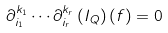<formula> <loc_0><loc_0><loc_500><loc_500>\partial _ { i _ { 1 } } ^ { k _ { 1 } } \cdots \partial _ { i _ { r } } ^ { k _ { r } } \left ( I _ { Q } \right ) ( f ) = 0</formula> 